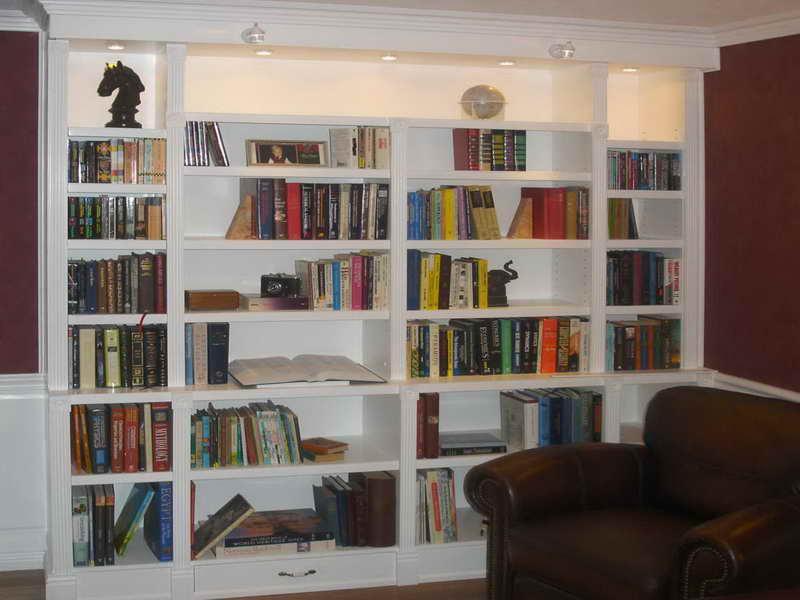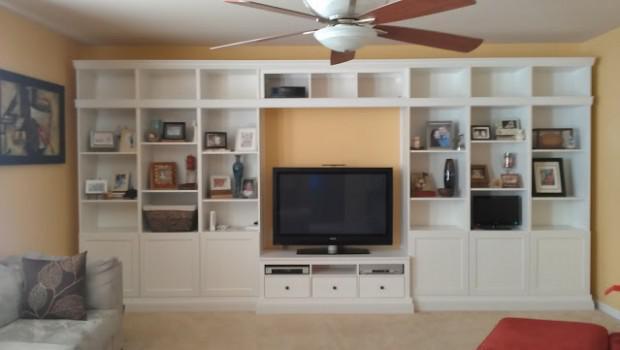The first image is the image on the left, the second image is the image on the right. Considering the images on both sides, is "In one image, a television is centered in a white wall unit that has open shelving in the upper section and solid panel doors and drawers across the bottom" valid? Answer yes or no. Yes. The first image is the image on the left, the second image is the image on the right. For the images displayed, is the sentence "A large flat-screen TV is flanked by vertical white bookshelves in one of the rooms." factually correct? Answer yes or no. Yes. 